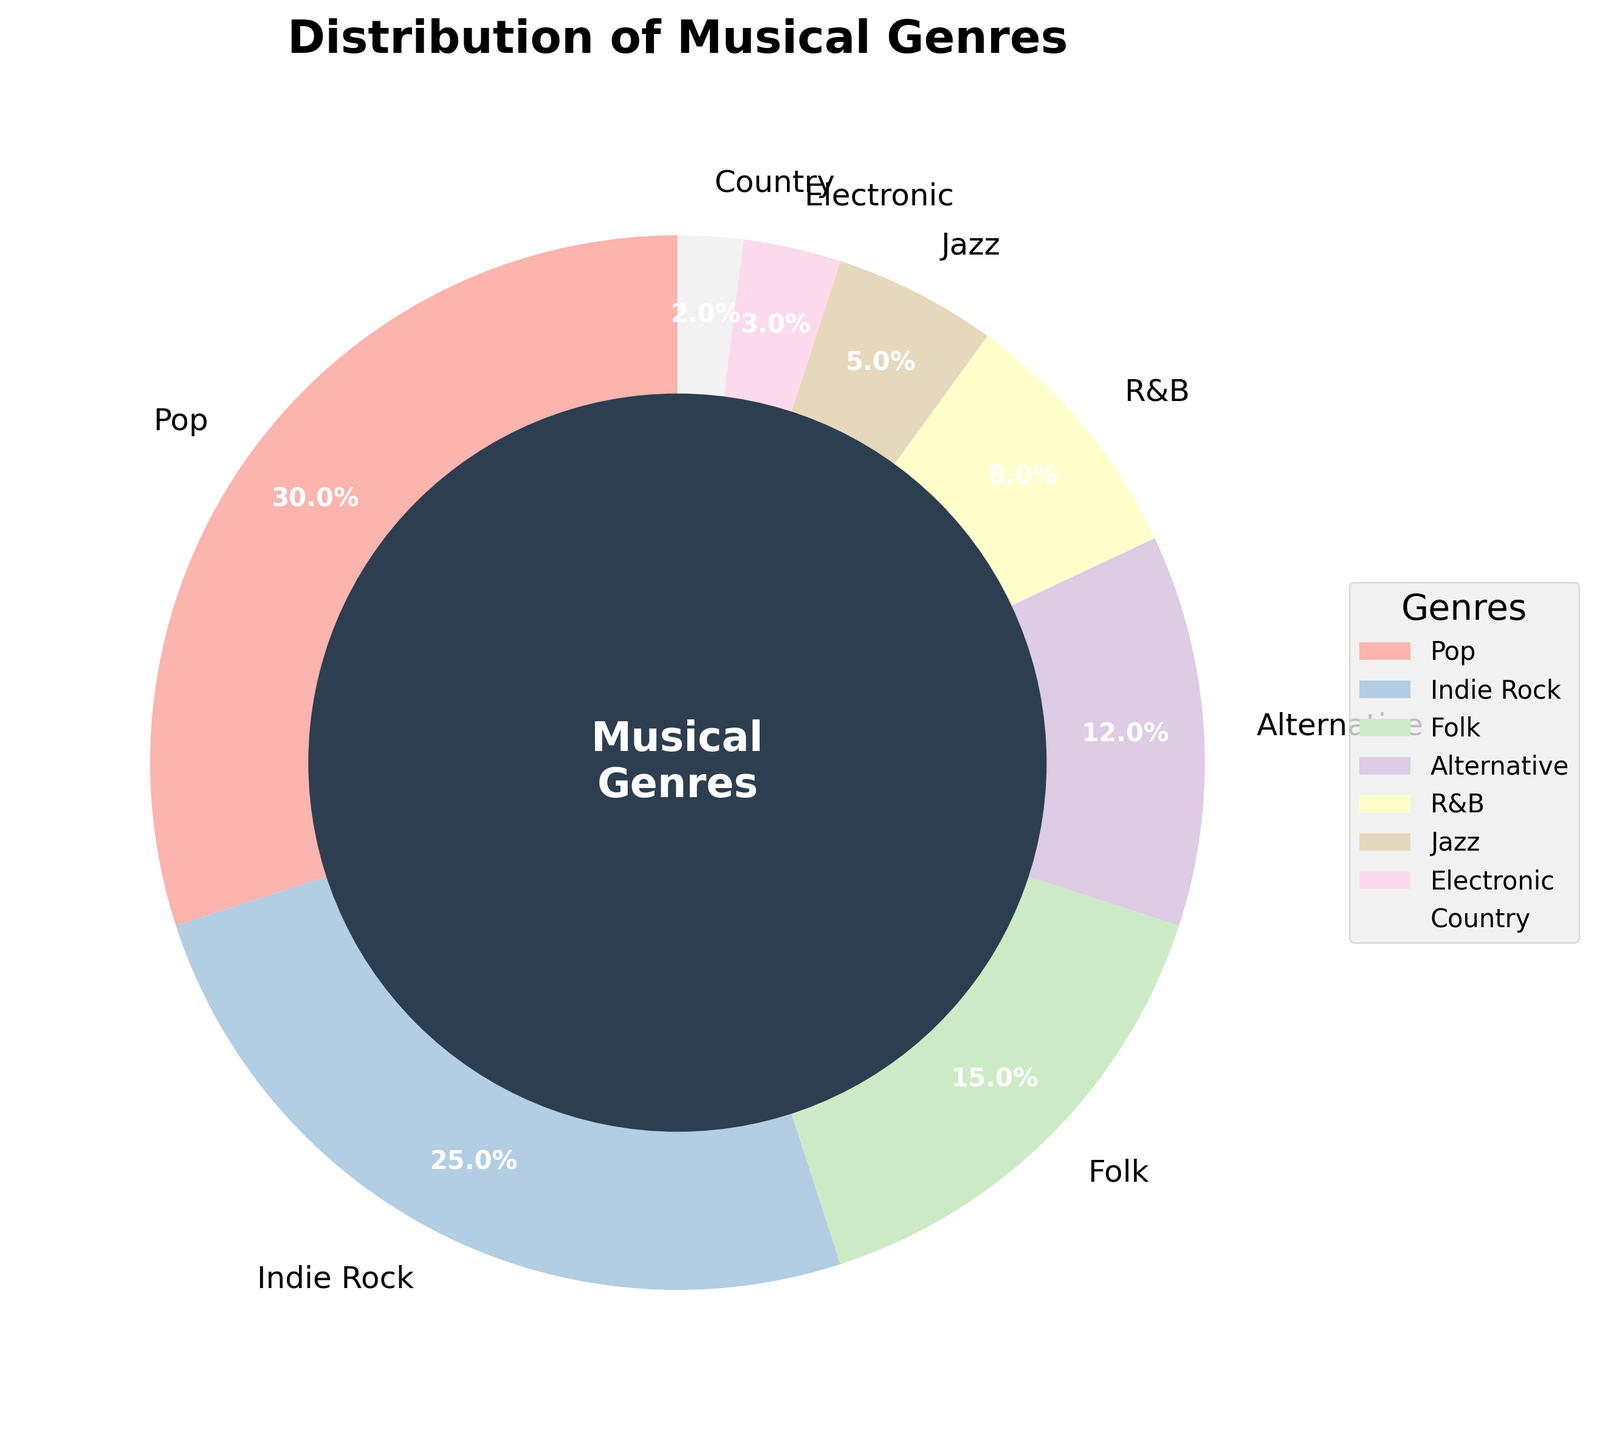What's the most performed musical genre? The pie chart shows that the largest wedge is labeled "Pop", which occupies 30% of the chart, indicating it's the most performed genre
Answer: Pop Which genres combined make up less than or equal to 10% of the performances? By referring to the chart, we identify the percentages: Electronic is 3% and Country is 2%. Summing these gives 3% + 2% = 5%, which is less than 10%
Answer: Electronic, Country How much more is Pop performed than Jazz? By comparing the percentages from the pie chart: Pop is performed 30% of the time, and Jazz is performed 5% of the time. The difference is 30% - 5% = 25%
Answer: 25% Is the sum of the percentages of R&B and Jazz more or less than the percentage for Indie Rock? The pie chart shows R&B at 8% and Jazz at 5%. Summing them gives 8% + 5% = 13%, which is less than Indie Rock's 25%
Answer: Less What genres have a percentage between 10% and 15%? The chart indicates that Folk is the only genre within the range, at 15%, while Alternative is close at 12%
Answer: Folk, Alternative Which genre is performed less, Alternative or R&B, and by how much? The chart shows Alternative at 12% and R&B at 8%. The difference is 12% - 8% = 4%
Answer: R&B, 4% What is the average percentage for the top three most performed genres? Pop, Indie Rock, and Folk are the top three genres. Their percentages are 30%, 25%, and 15%, respectively. The average is (30% + 25% + 15%) / 3 = 70% / 3 ≈ 23.33%
Answer: 23.33% What is the total percentage of performances for genres that are not within the top four most performed? The top four genres are Pop (30%), Indie Rock (25%), Folk (15%), and Alternative (12%). Summing them gives 30% + 25% + 15% + 12% = 82%. The remaining genres share 100% - 82% = 18% combined
Answer: 18% 